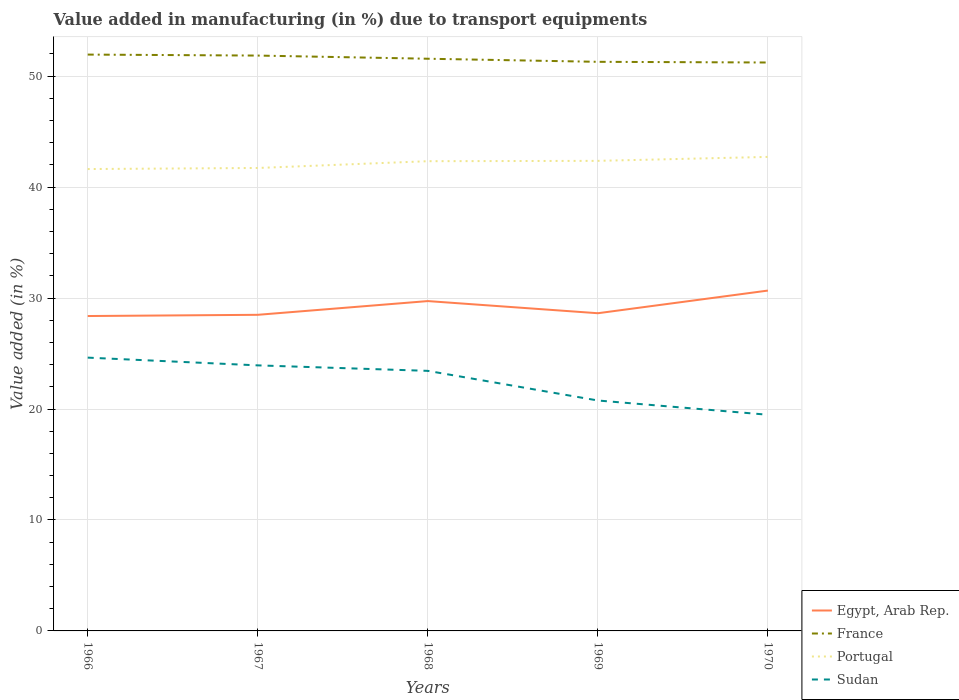Across all years, what is the maximum percentage of value added in manufacturing due to transport equipments in Egypt, Arab Rep.?
Provide a short and direct response. 28.38. In which year was the percentage of value added in manufacturing due to transport equipments in Egypt, Arab Rep. maximum?
Ensure brevity in your answer.  1966. What is the total percentage of value added in manufacturing due to transport equipments in France in the graph?
Give a very brief answer. 0.28. What is the difference between the highest and the second highest percentage of value added in manufacturing due to transport equipments in France?
Offer a very short reply. 0.71. Is the percentage of value added in manufacturing due to transport equipments in Sudan strictly greater than the percentage of value added in manufacturing due to transport equipments in Portugal over the years?
Ensure brevity in your answer.  Yes. How many years are there in the graph?
Offer a very short reply. 5. What is the difference between two consecutive major ticks on the Y-axis?
Provide a succinct answer. 10. What is the title of the graph?
Make the answer very short. Value added in manufacturing (in %) due to transport equipments. What is the label or title of the Y-axis?
Provide a short and direct response. Value added (in %). What is the Value added (in %) of Egypt, Arab Rep. in 1966?
Provide a short and direct response. 28.38. What is the Value added (in %) in France in 1966?
Ensure brevity in your answer.  51.94. What is the Value added (in %) in Portugal in 1966?
Provide a succinct answer. 41.63. What is the Value added (in %) of Sudan in 1966?
Provide a short and direct response. 24.63. What is the Value added (in %) in Egypt, Arab Rep. in 1967?
Ensure brevity in your answer.  28.49. What is the Value added (in %) of France in 1967?
Give a very brief answer. 51.86. What is the Value added (in %) in Portugal in 1967?
Offer a very short reply. 41.72. What is the Value added (in %) of Sudan in 1967?
Provide a short and direct response. 23.93. What is the Value added (in %) of Egypt, Arab Rep. in 1968?
Provide a short and direct response. 29.73. What is the Value added (in %) in France in 1968?
Provide a succinct answer. 51.57. What is the Value added (in %) in Portugal in 1968?
Your response must be concise. 42.34. What is the Value added (in %) in Sudan in 1968?
Ensure brevity in your answer.  23.44. What is the Value added (in %) in Egypt, Arab Rep. in 1969?
Provide a succinct answer. 28.63. What is the Value added (in %) of France in 1969?
Your response must be concise. 51.29. What is the Value added (in %) in Portugal in 1969?
Provide a short and direct response. 42.37. What is the Value added (in %) of Sudan in 1969?
Provide a short and direct response. 20.77. What is the Value added (in %) in Egypt, Arab Rep. in 1970?
Ensure brevity in your answer.  30.67. What is the Value added (in %) of France in 1970?
Your answer should be very brief. 51.23. What is the Value added (in %) in Portugal in 1970?
Give a very brief answer. 42.72. What is the Value added (in %) of Sudan in 1970?
Your answer should be very brief. 19.48. Across all years, what is the maximum Value added (in %) of Egypt, Arab Rep.?
Provide a short and direct response. 30.67. Across all years, what is the maximum Value added (in %) of France?
Ensure brevity in your answer.  51.94. Across all years, what is the maximum Value added (in %) in Portugal?
Ensure brevity in your answer.  42.72. Across all years, what is the maximum Value added (in %) of Sudan?
Offer a terse response. 24.63. Across all years, what is the minimum Value added (in %) of Egypt, Arab Rep.?
Your answer should be compact. 28.38. Across all years, what is the minimum Value added (in %) in France?
Keep it short and to the point. 51.23. Across all years, what is the minimum Value added (in %) in Portugal?
Ensure brevity in your answer.  41.63. Across all years, what is the minimum Value added (in %) in Sudan?
Your response must be concise. 19.48. What is the total Value added (in %) in Egypt, Arab Rep. in the graph?
Provide a short and direct response. 145.91. What is the total Value added (in %) of France in the graph?
Your answer should be compact. 257.89. What is the total Value added (in %) in Portugal in the graph?
Make the answer very short. 210.77. What is the total Value added (in %) of Sudan in the graph?
Give a very brief answer. 112.25. What is the difference between the Value added (in %) in Egypt, Arab Rep. in 1966 and that in 1967?
Make the answer very short. -0.11. What is the difference between the Value added (in %) of France in 1966 and that in 1967?
Your response must be concise. 0.09. What is the difference between the Value added (in %) of Portugal in 1966 and that in 1967?
Offer a very short reply. -0.1. What is the difference between the Value added (in %) in Sudan in 1966 and that in 1967?
Ensure brevity in your answer.  0.7. What is the difference between the Value added (in %) in Egypt, Arab Rep. in 1966 and that in 1968?
Give a very brief answer. -1.35. What is the difference between the Value added (in %) of France in 1966 and that in 1968?
Offer a terse response. 0.37. What is the difference between the Value added (in %) in Portugal in 1966 and that in 1968?
Keep it short and to the point. -0.71. What is the difference between the Value added (in %) of Sudan in 1966 and that in 1968?
Ensure brevity in your answer.  1.19. What is the difference between the Value added (in %) of Egypt, Arab Rep. in 1966 and that in 1969?
Offer a very short reply. -0.25. What is the difference between the Value added (in %) in France in 1966 and that in 1969?
Give a very brief answer. 0.65. What is the difference between the Value added (in %) of Portugal in 1966 and that in 1969?
Make the answer very short. -0.74. What is the difference between the Value added (in %) in Sudan in 1966 and that in 1969?
Your answer should be compact. 3.86. What is the difference between the Value added (in %) in Egypt, Arab Rep. in 1966 and that in 1970?
Your answer should be very brief. -2.29. What is the difference between the Value added (in %) of France in 1966 and that in 1970?
Your response must be concise. 0.71. What is the difference between the Value added (in %) of Portugal in 1966 and that in 1970?
Offer a very short reply. -1.09. What is the difference between the Value added (in %) in Sudan in 1966 and that in 1970?
Your answer should be very brief. 5.15. What is the difference between the Value added (in %) of Egypt, Arab Rep. in 1967 and that in 1968?
Your answer should be very brief. -1.24. What is the difference between the Value added (in %) of France in 1967 and that in 1968?
Provide a succinct answer. 0.29. What is the difference between the Value added (in %) in Portugal in 1967 and that in 1968?
Offer a terse response. -0.61. What is the difference between the Value added (in %) in Sudan in 1967 and that in 1968?
Your answer should be compact. 0.49. What is the difference between the Value added (in %) in Egypt, Arab Rep. in 1967 and that in 1969?
Provide a short and direct response. -0.14. What is the difference between the Value added (in %) of France in 1967 and that in 1969?
Offer a terse response. 0.56. What is the difference between the Value added (in %) in Portugal in 1967 and that in 1969?
Offer a terse response. -0.64. What is the difference between the Value added (in %) in Sudan in 1967 and that in 1969?
Offer a very short reply. 3.17. What is the difference between the Value added (in %) in Egypt, Arab Rep. in 1967 and that in 1970?
Provide a succinct answer. -2.18. What is the difference between the Value added (in %) in France in 1967 and that in 1970?
Offer a very short reply. 0.63. What is the difference between the Value added (in %) in Portugal in 1967 and that in 1970?
Offer a very short reply. -1. What is the difference between the Value added (in %) of Sudan in 1967 and that in 1970?
Provide a short and direct response. 4.45. What is the difference between the Value added (in %) in Egypt, Arab Rep. in 1968 and that in 1969?
Keep it short and to the point. 1.09. What is the difference between the Value added (in %) in France in 1968 and that in 1969?
Your answer should be compact. 0.28. What is the difference between the Value added (in %) of Portugal in 1968 and that in 1969?
Keep it short and to the point. -0.03. What is the difference between the Value added (in %) of Sudan in 1968 and that in 1969?
Ensure brevity in your answer.  2.67. What is the difference between the Value added (in %) in Egypt, Arab Rep. in 1968 and that in 1970?
Offer a terse response. -0.95. What is the difference between the Value added (in %) of France in 1968 and that in 1970?
Ensure brevity in your answer.  0.34. What is the difference between the Value added (in %) of Portugal in 1968 and that in 1970?
Your answer should be compact. -0.39. What is the difference between the Value added (in %) in Sudan in 1968 and that in 1970?
Your answer should be very brief. 3.96. What is the difference between the Value added (in %) in Egypt, Arab Rep. in 1969 and that in 1970?
Your response must be concise. -2.04. What is the difference between the Value added (in %) of France in 1969 and that in 1970?
Offer a terse response. 0.06. What is the difference between the Value added (in %) in Portugal in 1969 and that in 1970?
Make the answer very short. -0.36. What is the difference between the Value added (in %) in Sudan in 1969 and that in 1970?
Your answer should be compact. 1.29. What is the difference between the Value added (in %) of Egypt, Arab Rep. in 1966 and the Value added (in %) of France in 1967?
Your response must be concise. -23.48. What is the difference between the Value added (in %) in Egypt, Arab Rep. in 1966 and the Value added (in %) in Portugal in 1967?
Ensure brevity in your answer.  -13.34. What is the difference between the Value added (in %) in Egypt, Arab Rep. in 1966 and the Value added (in %) in Sudan in 1967?
Offer a terse response. 4.45. What is the difference between the Value added (in %) of France in 1966 and the Value added (in %) of Portugal in 1967?
Offer a terse response. 10.22. What is the difference between the Value added (in %) of France in 1966 and the Value added (in %) of Sudan in 1967?
Keep it short and to the point. 28.01. What is the difference between the Value added (in %) of Portugal in 1966 and the Value added (in %) of Sudan in 1967?
Your answer should be very brief. 17.69. What is the difference between the Value added (in %) in Egypt, Arab Rep. in 1966 and the Value added (in %) in France in 1968?
Your answer should be compact. -23.19. What is the difference between the Value added (in %) of Egypt, Arab Rep. in 1966 and the Value added (in %) of Portugal in 1968?
Offer a very short reply. -13.96. What is the difference between the Value added (in %) in Egypt, Arab Rep. in 1966 and the Value added (in %) in Sudan in 1968?
Offer a terse response. 4.94. What is the difference between the Value added (in %) of France in 1966 and the Value added (in %) of Portugal in 1968?
Your answer should be very brief. 9.61. What is the difference between the Value added (in %) of France in 1966 and the Value added (in %) of Sudan in 1968?
Give a very brief answer. 28.5. What is the difference between the Value added (in %) in Portugal in 1966 and the Value added (in %) in Sudan in 1968?
Provide a succinct answer. 18.19. What is the difference between the Value added (in %) of Egypt, Arab Rep. in 1966 and the Value added (in %) of France in 1969?
Keep it short and to the point. -22.91. What is the difference between the Value added (in %) of Egypt, Arab Rep. in 1966 and the Value added (in %) of Portugal in 1969?
Your answer should be compact. -13.99. What is the difference between the Value added (in %) of Egypt, Arab Rep. in 1966 and the Value added (in %) of Sudan in 1969?
Your response must be concise. 7.61. What is the difference between the Value added (in %) of France in 1966 and the Value added (in %) of Portugal in 1969?
Your response must be concise. 9.58. What is the difference between the Value added (in %) of France in 1966 and the Value added (in %) of Sudan in 1969?
Make the answer very short. 31.18. What is the difference between the Value added (in %) of Portugal in 1966 and the Value added (in %) of Sudan in 1969?
Your answer should be very brief. 20.86. What is the difference between the Value added (in %) in Egypt, Arab Rep. in 1966 and the Value added (in %) in France in 1970?
Offer a very short reply. -22.85. What is the difference between the Value added (in %) in Egypt, Arab Rep. in 1966 and the Value added (in %) in Portugal in 1970?
Provide a succinct answer. -14.34. What is the difference between the Value added (in %) of Egypt, Arab Rep. in 1966 and the Value added (in %) of Sudan in 1970?
Your response must be concise. 8.9. What is the difference between the Value added (in %) of France in 1966 and the Value added (in %) of Portugal in 1970?
Your answer should be very brief. 9.22. What is the difference between the Value added (in %) of France in 1966 and the Value added (in %) of Sudan in 1970?
Make the answer very short. 32.46. What is the difference between the Value added (in %) in Portugal in 1966 and the Value added (in %) in Sudan in 1970?
Your answer should be compact. 22.14. What is the difference between the Value added (in %) in Egypt, Arab Rep. in 1967 and the Value added (in %) in France in 1968?
Give a very brief answer. -23.08. What is the difference between the Value added (in %) in Egypt, Arab Rep. in 1967 and the Value added (in %) in Portugal in 1968?
Offer a very short reply. -13.85. What is the difference between the Value added (in %) in Egypt, Arab Rep. in 1967 and the Value added (in %) in Sudan in 1968?
Your answer should be very brief. 5.05. What is the difference between the Value added (in %) in France in 1967 and the Value added (in %) in Portugal in 1968?
Give a very brief answer. 9.52. What is the difference between the Value added (in %) of France in 1967 and the Value added (in %) of Sudan in 1968?
Give a very brief answer. 28.42. What is the difference between the Value added (in %) in Portugal in 1967 and the Value added (in %) in Sudan in 1968?
Your response must be concise. 18.28. What is the difference between the Value added (in %) in Egypt, Arab Rep. in 1967 and the Value added (in %) in France in 1969?
Your response must be concise. -22.8. What is the difference between the Value added (in %) in Egypt, Arab Rep. in 1967 and the Value added (in %) in Portugal in 1969?
Offer a very short reply. -13.88. What is the difference between the Value added (in %) in Egypt, Arab Rep. in 1967 and the Value added (in %) in Sudan in 1969?
Offer a terse response. 7.72. What is the difference between the Value added (in %) of France in 1967 and the Value added (in %) of Portugal in 1969?
Ensure brevity in your answer.  9.49. What is the difference between the Value added (in %) in France in 1967 and the Value added (in %) in Sudan in 1969?
Your response must be concise. 31.09. What is the difference between the Value added (in %) of Portugal in 1967 and the Value added (in %) of Sudan in 1969?
Offer a very short reply. 20.96. What is the difference between the Value added (in %) of Egypt, Arab Rep. in 1967 and the Value added (in %) of France in 1970?
Your answer should be compact. -22.74. What is the difference between the Value added (in %) in Egypt, Arab Rep. in 1967 and the Value added (in %) in Portugal in 1970?
Give a very brief answer. -14.23. What is the difference between the Value added (in %) of Egypt, Arab Rep. in 1967 and the Value added (in %) of Sudan in 1970?
Offer a very short reply. 9.01. What is the difference between the Value added (in %) in France in 1967 and the Value added (in %) in Portugal in 1970?
Make the answer very short. 9.13. What is the difference between the Value added (in %) in France in 1967 and the Value added (in %) in Sudan in 1970?
Offer a very short reply. 32.37. What is the difference between the Value added (in %) of Portugal in 1967 and the Value added (in %) of Sudan in 1970?
Your response must be concise. 22.24. What is the difference between the Value added (in %) of Egypt, Arab Rep. in 1968 and the Value added (in %) of France in 1969?
Provide a succinct answer. -21.56. What is the difference between the Value added (in %) in Egypt, Arab Rep. in 1968 and the Value added (in %) in Portugal in 1969?
Ensure brevity in your answer.  -12.64. What is the difference between the Value added (in %) of Egypt, Arab Rep. in 1968 and the Value added (in %) of Sudan in 1969?
Offer a terse response. 8.96. What is the difference between the Value added (in %) in France in 1968 and the Value added (in %) in Portugal in 1969?
Your response must be concise. 9.2. What is the difference between the Value added (in %) in France in 1968 and the Value added (in %) in Sudan in 1969?
Ensure brevity in your answer.  30.8. What is the difference between the Value added (in %) of Portugal in 1968 and the Value added (in %) of Sudan in 1969?
Give a very brief answer. 21.57. What is the difference between the Value added (in %) of Egypt, Arab Rep. in 1968 and the Value added (in %) of France in 1970?
Offer a terse response. -21.5. What is the difference between the Value added (in %) of Egypt, Arab Rep. in 1968 and the Value added (in %) of Portugal in 1970?
Keep it short and to the point. -13. What is the difference between the Value added (in %) in Egypt, Arab Rep. in 1968 and the Value added (in %) in Sudan in 1970?
Your answer should be compact. 10.24. What is the difference between the Value added (in %) in France in 1968 and the Value added (in %) in Portugal in 1970?
Your answer should be compact. 8.85. What is the difference between the Value added (in %) in France in 1968 and the Value added (in %) in Sudan in 1970?
Give a very brief answer. 32.09. What is the difference between the Value added (in %) in Portugal in 1968 and the Value added (in %) in Sudan in 1970?
Keep it short and to the point. 22.85. What is the difference between the Value added (in %) of Egypt, Arab Rep. in 1969 and the Value added (in %) of France in 1970?
Your answer should be very brief. -22.6. What is the difference between the Value added (in %) of Egypt, Arab Rep. in 1969 and the Value added (in %) of Portugal in 1970?
Ensure brevity in your answer.  -14.09. What is the difference between the Value added (in %) of Egypt, Arab Rep. in 1969 and the Value added (in %) of Sudan in 1970?
Your response must be concise. 9.15. What is the difference between the Value added (in %) of France in 1969 and the Value added (in %) of Portugal in 1970?
Provide a short and direct response. 8.57. What is the difference between the Value added (in %) in France in 1969 and the Value added (in %) in Sudan in 1970?
Your answer should be very brief. 31.81. What is the difference between the Value added (in %) in Portugal in 1969 and the Value added (in %) in Sudan in 1970?
Your answer should be compact. 22.88. What is the average Value added (in %) in Egypt, Arab Rep. per year?
Keep it short and to the point. 29.18. What is the average Value added (in %) in France per year?
Your answer should be compact. 51.58. What is the average Value added (in %) of Portugal per year?
Offer a terse response. 42.15. What is the average Value added (in %) in Sudan per year?
Make the answer very short. 22.45. In the year 1966, what is the difference between the Value added (in %) of Egypt, Arab Rep. and Value added (in %) of France?
Your answer should be very brief. -23.56. In the year 1966, what is the difference between the Value added (in %) in Egypt, Arab Rep. and Value added (in %) in Portugal?
Offer a terse response. -13.25. In the year 1966, what is the difference between the Value added (in %) of Egypt, Arab Rep. and Value added (in %) of Sudan?
Provide a short and direct response. 3.75. In the year 1966, what is the difference between the Value added (in %) in France and Value added (in %) in Portugal?
Make the answer very short. 10.32. In the year 1966, what is the difference between the Value added (in %) of France and Value added (in %) of Sudan?
Give a very brief answer. 27.31. In the year 1966, what is the difference between the Value added (in %) of Portugal and Value added (in %) of Sudan?
Offer a terse response. 17. In the year 1967, what is the difference between the Value added (in %) in Egypt, Arab Rep. and Value added (in %) in France?
Your response must be concise. -23.37. In the year 1967, what is the difference between the Value added (in %) of Egypt, Arab Rep. and Value added (in %) of Portugal?
Offer a terse response. -13.23. In the year 1967, what is the difference between the Value added (in %) of Egypt, Arab Rep. and Value added (in %) of Sudan?
Your answer should be very brief. 4.56. In the year 1967, what is the difference between the Value added (in %) in France and Value added (in %) in Portugal?
Keep it short and to the point. 10.13. In the year 1967, what is the difference between the Value added (in %) of France and Value added (in %) of Sudan?
Make the answer very short. 27.92. In the year 1967, what is the difference between the Value added (in %) of Portugal and Value added (in %) of Sudan?
Make the answer very short. 17.79. In the year 1968, what is the difference between the Value added (in %) of Egypt, Arab Rep. and Value added (in %) of France?
Provide a short and direct response. -21.84. In the year 1968, what is the difference between the Value added (in %) in Egypt, Arab Rep. and Value added (in %) in Portugal?
Offer a very short reply. -12.61. In the year 1968, what is the difference between the Value added (in %) of Egypt, Arab Rep. and Value added (in %) of Sudan?
Ensure brevity in your answer.  6.29. In the year 1968, what is the difference between the Value added (in %) of France and Value added (in %) of Portugal?
Offer a very short reply. 9.23. In the year 1968, what is the difference between the Value added (in %) in France and Value added (in %) in Sudan?
Give a very brief answer. 28.13. In the year 1968, what is the difference between the Value added (in %) of Portugal and Value added (in %) of Sudan?
Ensure brevity in your answer.  18.9. In the year 1969, what is the difference between the Value added (in %) in Egypt, Arab Rep. and Value added (in %) in France?
Your answer should be compact. -22.66. In the year 1969, what is the difference between the Value added (in %) of Egypt, Arab Rep. and Value added (in %) of Portugal?
Your response must be concise. -13.73. In the year 1969, what is the difference between the Value added (in %) of Egypt, Arab Rep. and Value added (in %) of Sudan?
Your response must be concise. 7.87. In the year 1969, what is the difference between the Value added (in %) of France and Value added (in %) of Portugal?
Provide a succinct answer. 8.93. In the year 1969, what is the difference between the Value added (in %) of France and Value added (in %) of Sudan?
Your response must be concise. 30.52. In the year 1969, what is the difference between the Value added (in %) of Portugal and Value added (in %) of Sudan?
Make the answer very short. 21.6. In the year 1970, what is the difference between the Value added (in %) of Egypt, Arab Rep. and Value added (in %) of France?
Give a very brief answer. -20.56. In the year 1970, what is the difference between the Value added (in %) in Egypt, Arab Rep. and Value added (in %) in Portugal?
Your answer should be very brief. -12.05. In the year 1970, what is the difference between the Value added (in %) in Egypt, Arab Rep. and Value added (in %) in Sudan?
Your answer should be very brief. 11.19. In the year 1970, what is the difference between the Value added (in %) in France and Value added (in %) in Portugal?
Ensure brevity in your answer.  8.51. In the year 1970, what is the difference between the Value added (in %) in France and Value added (in %) in Sudan?
Offer a very short reply. 31.75. In the year 1970, what is the difference between the Value added (in %) in Portugal and Value added (in %) in Sudan?
Offer a very short reply. 23.24. What is the ratio of the Value added (in %) of France in 1966 to that in 1967?
Give a very brief answer. 1. What is the ratio of the Value added (in %) in Sudan in 1966 to that in 1967?
Give a very brief answer. 1.03. What is the ratio of the Value added (in %) of Egypt, Arab Rep. in 1966 to that in 1968?
Your response must be concise. 0.95. What is the ratio of the Value added (in %) in France in 1966 to that in 1968?
Keep it short and to the point. 1.01. What is the ratio of the Value added (in %) in Portugal in 1966 to that in 1968?
Provide a short and direct response. 0.98. What is the ratio of the Value added (in %) of Sudan in 1966 to that in 1968?
Your answer should be compact. 1.05. What is the ratio of the Value added (in %) in France in 1966 to that in 1969?
Give a very brief answer. 1.01. What is the ratio of the Value added (in %) of Portugal in 1966 to that in 1969?
Provide a short and direct response. 0.98. What is the ratio of the Value added (in %) in Sudan in 1966 to that in 1969?
Offer a terse response. 1.19. What is the ratio of the Value added (in %) in Egypt, Arab Rep. in 1966 to that in 1970?
Provide a succinct answer. 0.93. What is the ratio of the Value added (in %) of France in 1966 to that in 1970?
Your answer should be compact. 1.01. What is the ratio of the Value added (in %) in Portugal in 1966 to that in 1970?
Your response must be concise. 0.97. What is the ratio of the Value added (in %) in Sudan in 1966 to that in 1970?
Provide a short and direct response. 1.26. What is the ratio of the Value added (in %) of Egypt, Arab Rep. in 1967 to that in 1968?
Your answer should be very brief. 0.96. What is the ratio of the Value added (in %) of France in 1967 to that in 1968?
Ensure brevity in your answer.  1.01. What is the ratio of the Value added (in %) of Portugal in 1967 to that in 1968?
Keep it short and to the point. 0.99. What is the ratio of the Value added (in %) of Sudan in 1967 to that in 1968?
Make the answer very short. 1.02. What is the ratio of the Value added (in %) in Egypt, Arab Rep. in 1967 to that in 1969?
Your response must be concise. 0.99. What is the ratio of the Value added (in %) of France in 1967 to that in 1969?
Offer a terse response. 1.01. What is the ratio of the Value added (in %) of Portugal in 1967 to that in 1969?
Ensure brevity in your answer.  0.98. What is the ratio of the Value added (in %) in Sudan in 1967 to that in 1969?
Give a very brief answer. 1.15. What is the ratio of the Value added (in %) in Egypt, Arab Rep. in 1967 to that in 1970?
Offer a very short reply. 0.93. What is the ratio of the Value added (in %) of France in 1967 to that in 1970?
Ensure brevity in your answer.  1.01. What is the ratio of the Value added (in %) of Portugal in 1967 to that in 1970?
Offer a terse response. 0.98. What is the ratio of the Value added (in %) in Sudan in 1967 to that in 1970?
Offer a very short reply. 1.23. What is the ratio of the Value added (in %) in Egypt, Arab Rep. in 1968 to that in 1969?
Keep it short and to the point. 1.04. What is the ratio of the Value added (in %) of France in 1968 to that in 1969?
Provide a short and direct response. 1.01. What is the ratio of the Value added (in %) in Portugal in 1968 to that in 1969?
Your response must be concise. 1. What is the ratio of the Value added (in %) in Sudan in 1968 to that in 1969?
Make the answer very short. 1.13. What is the ratio of the Value added (in %) in Egypt, Arab Rep. in 1968 to that in 1970?
Provide a short and direct response. 0.97. What is the ratio of the Value added (in %) in France in 1968 to that in 1970?
Your answer should be very brief. 1.01. What is the ratio of the Value added (in %) in Portugal in 1968 to that in 1970?
Provide a short and direct response. 0.99. What is the ratio of the Value added (in %) in Sudan in 1968 to that in 1970?
Keep it short and to the point. 1.2. What is the ratio of the Value added (in %) of Egypt, Arab Rep. in 1969 to that in 1970?
Offer a very short reply. 0.93. What is the ratio of the Value added (in %) of Portugal in 1969 to that in 1970?
Keep it short and to the point. 0.99. What is the ratio of the Value added (in %) in Sudan in 1969 to that in 1970?
Your response must be concise. 1.07. What is the difference between the highest and the second highest Value added (in %) of Egypt, Arab Rep.?
Provide a short and direct response. 0.95. What is the difference between the highest and the second highest Value added (in %) of France?
Offer a very short reply. 0.09. What is the difference between the highest and the second highest Value added (in %) of Portugal?
Offer a terse response. 0.36. What is the difference between the highest and the second highest Value added (in %) of Sudan?
Provide a succinct answer. 0.7. What is the difference between the highest and the lowest Value added (in %) in Egypt, Arab Rep.?
Offer a very short reply. 2.29. What is the difference between the highest and the lowest Value added (in %) of France?
Your answer should be compact. 0.71. What is the difference between the highest and the lowest Value added (in %) of Portugal?
Keep it short and to the point. 1.09. What is the difference between the highest and the lowest Value added (in %) of Sudan?
Provide a short and direct response. 5.15. 